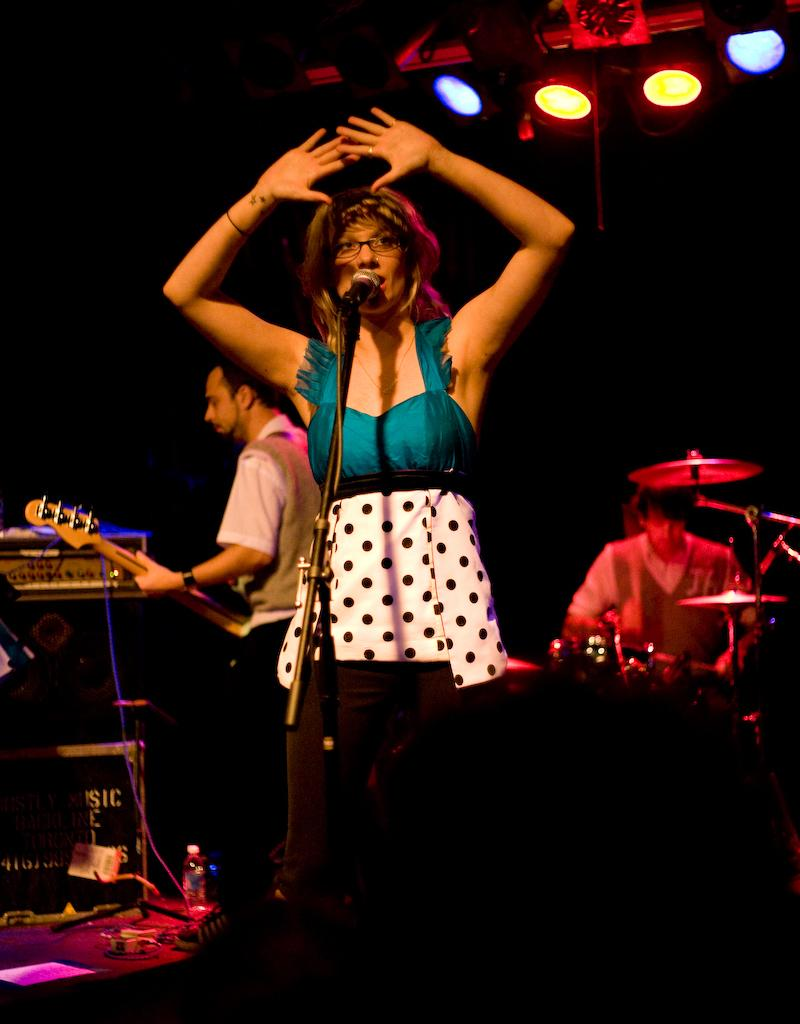Who is the main subject in the image? There is a woman in the image. What is the woman doing in the image? The woman is talking into a microphone. Can you describe the background of the image? There is a person holding a guitar and another person playing a musical instrument in the background. What can be seen in terms of lighting in the image? There are lights visible in the image. What type of iron can be seen on the ground in the image? There is no iron visible on the ground in the image. What kind of land is depicted in the image? The image does not show any specific type of land; it primarily features a woman talking into a microphone and a background with musical instruments. 